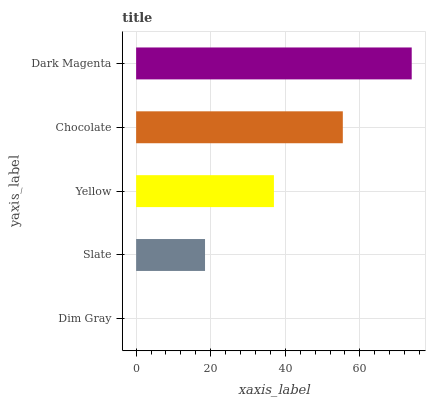Is Dim Gray the minimum?
Answer yes or no. Yes. Is Dark Magenta the maximum?
Answer yes or no. Yes. Is Slate the minimum?
Answer yes or no. No. Is Slate the maximum?
Answer yes or no. No. Is Slate greater than Dim Gray?
Answer yes or no. Yes. Is Dim Gray less than Slate?
Answer yes or no. Yes. Is Dim Gray greater than Slate?
Answer yes or no. No. Is Slate less than Dim Gray?
Answer yes or no. No. Is Yellow the high median?
Answer yes or no. Yes. Is Yellow the low median?
Answer yes or no. Yes. Is Chocolate the high median?
Answer yes or no. No. Is Chocolate the low median?
Answer yes or no. No. 